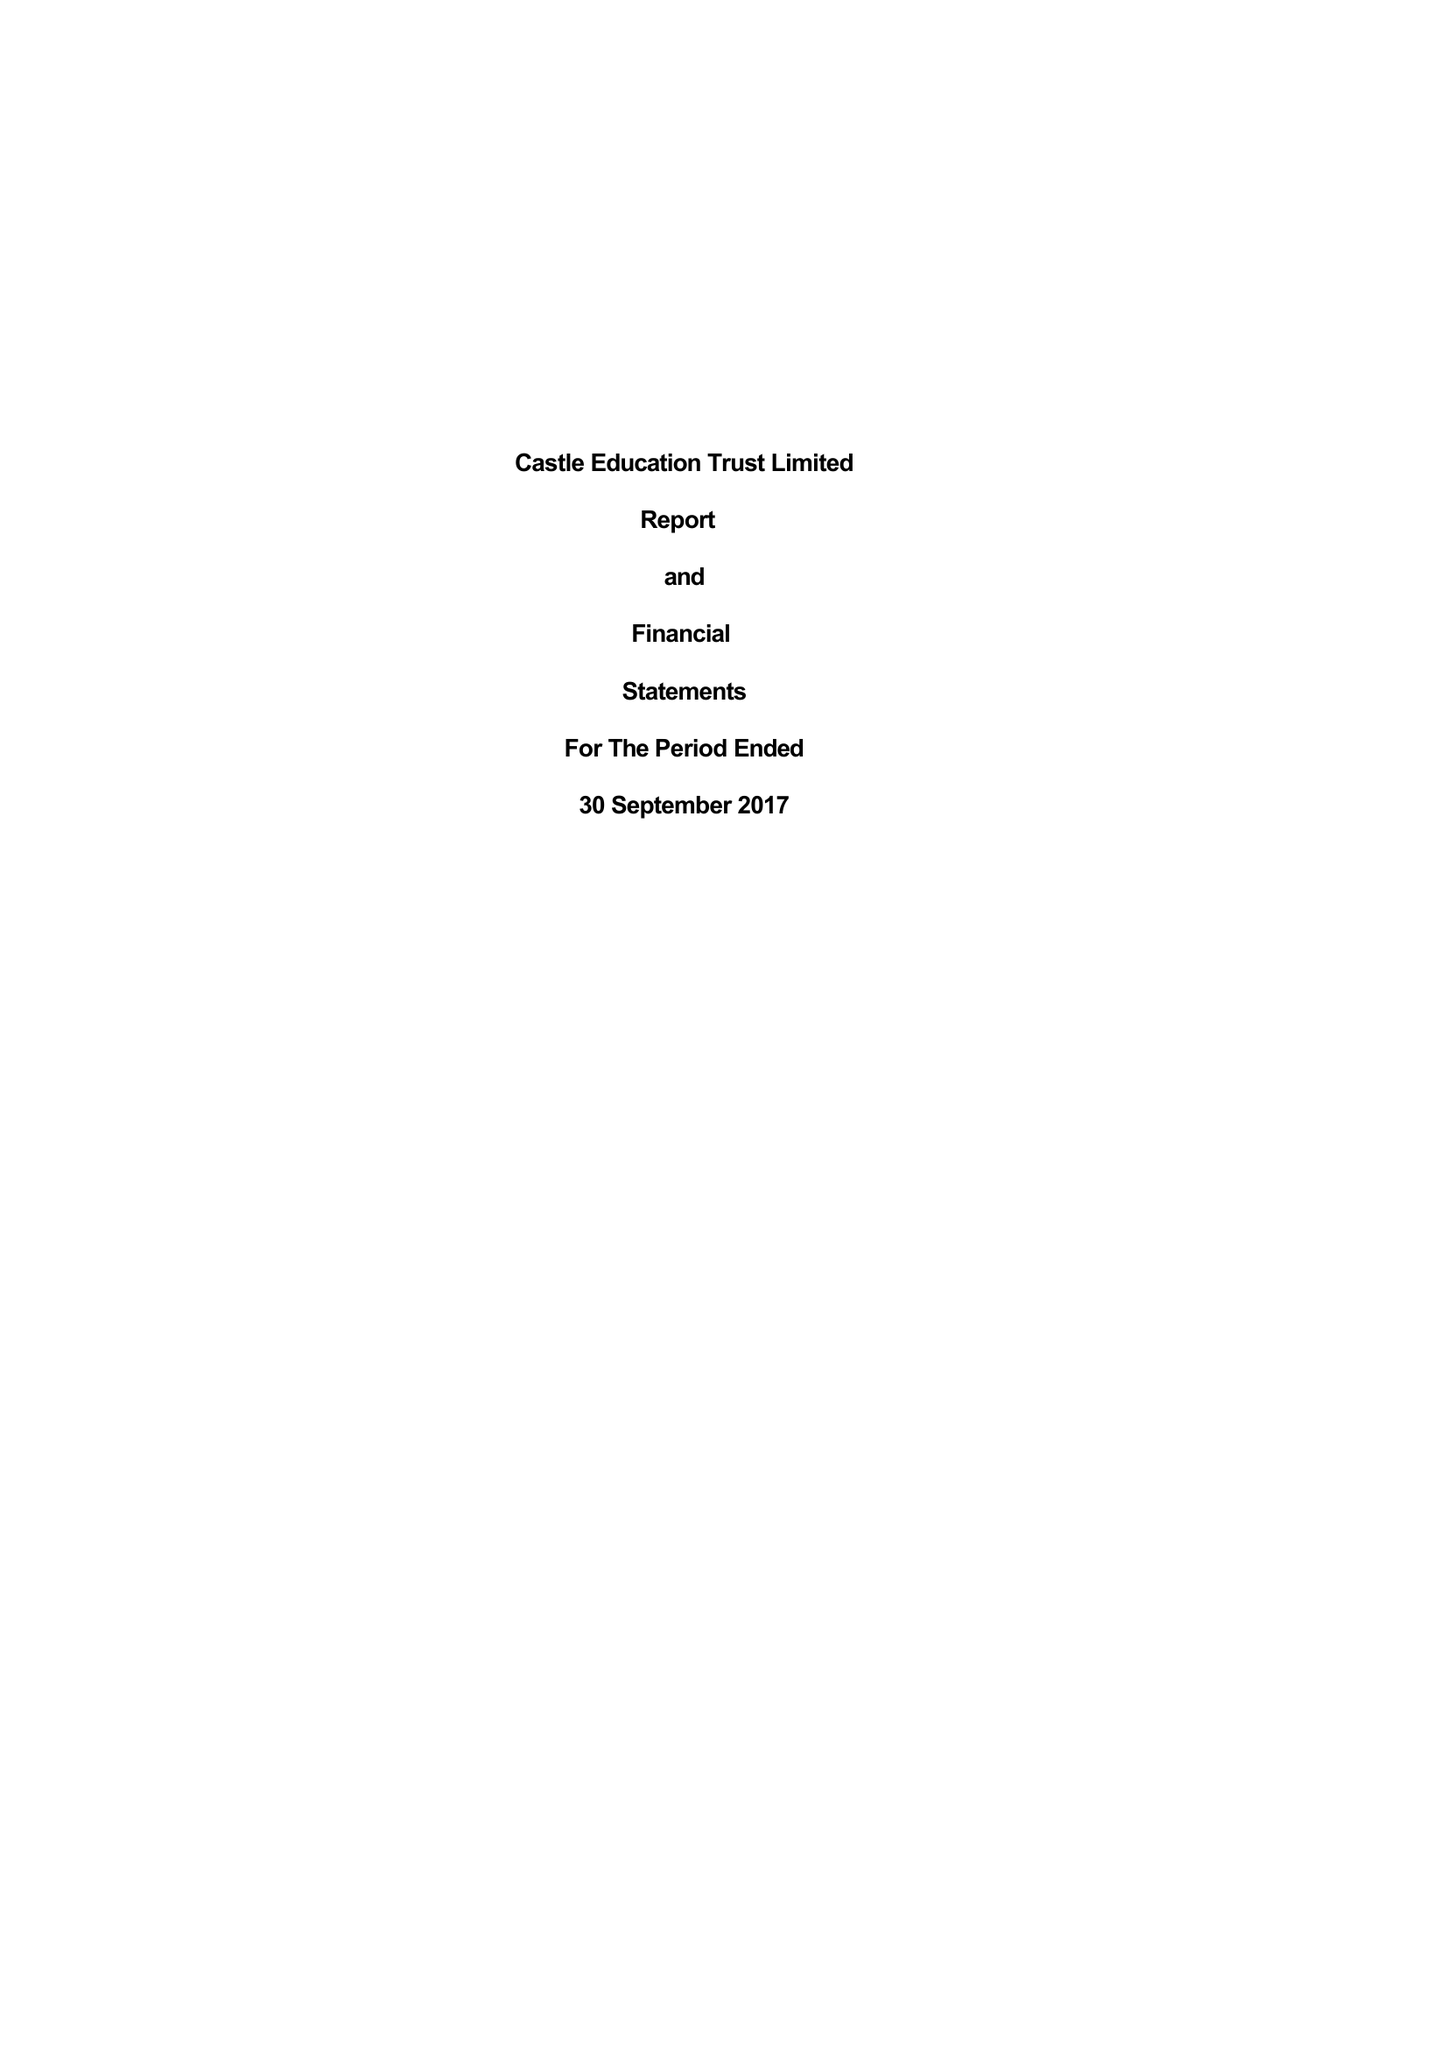What is the value for the income_annually_in_british_pounds?
Answer the question using a single word or phrase. 47728.00 